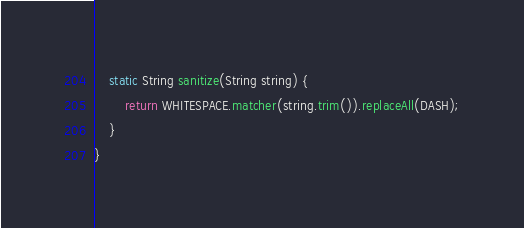Convert code to text. <code><loc_0><loc_0><loc_500><loc_500><_Java_>    static String sanitize(String string) {
        return WHITESPACE.matcher(string.trim()).replaceAll(DASH);
    }
}
</code> 